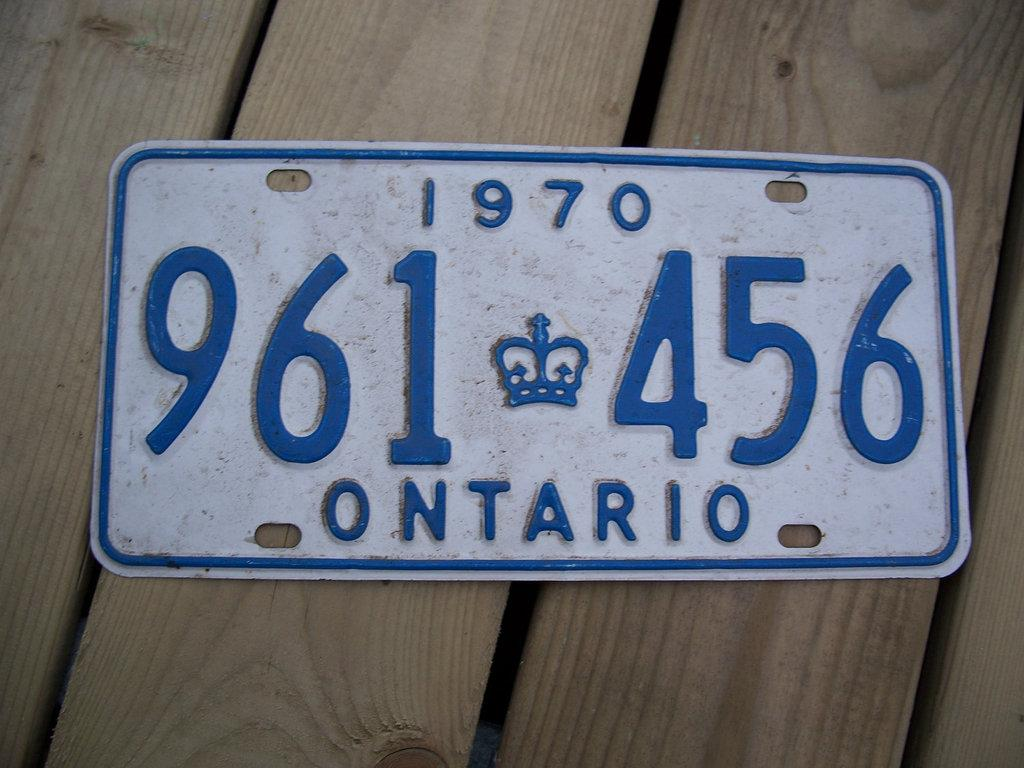<image>
Render a clear and concise summary of the photo. An older looking blue and white license plate that reads 1970 on the top, 961 456 in the middle and Ontario on the bottom. 